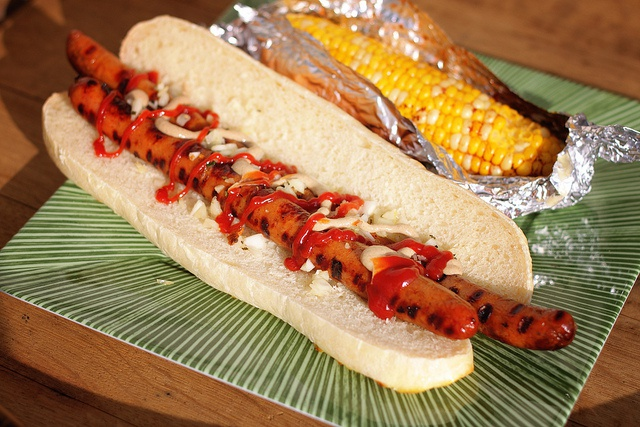Describe the objects in this image and their specific colors. I can see a hot dog in brown, tan, and beige tones in this image. 